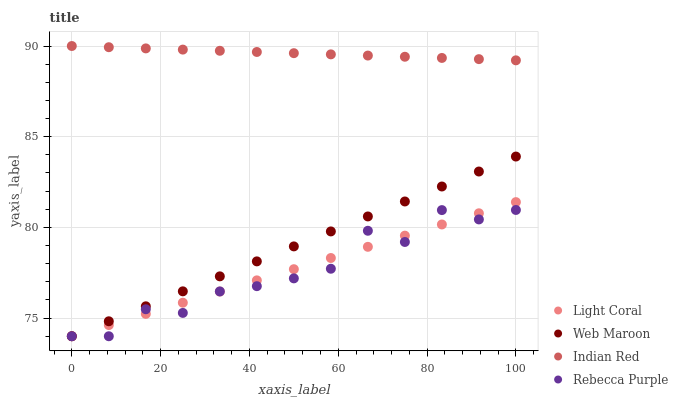Does Rebecca Purple have the minimum area under the curve?
Answer yes or no. Yes. Does Indian Red have the maximum area under the curve?
Answer yes or no. Yes. Does Web Maroon have the minimum area under the curve?
Answer yes or no. No. Does Web Maroon have the maximum area under the curve?
Answer yes or no. No. Is Light Coral the smoothest?
Answer yes or no. Yes. Is Rebecca Purple the roughest?
Answer yes or no. Yes. Is Web Maroon the smoothest?
Answer yes or no. No. Is Web Maroon the roughest?
Answer yes or no. No. Does Light Coral have the lowest value?
Answer yes or no. Yes. Does Indian Red have the lowest value?
Answer yes or no. No. Does Indian Red have the highest value?
Answer yes or no. Yes. Does Web Maroon have the highest value?
Answer yes or no. No. Is Light Coral less than Indian Red?
Answer yes or no. Yes. Is Indian Red greater than Rebecca Purple?
Answer yes or no. Yes. Does Light Coral intersect Rebecca Purple?
Answer yes or no. Yes. Is Light Coral less than Rebecca Purple?
Answer yes or no. No. Is Light Coral greater than Rebecca Purple?
Answer yes or no. No. Does Light Coral intersect Indian Red?
Answer yes or no. No. 